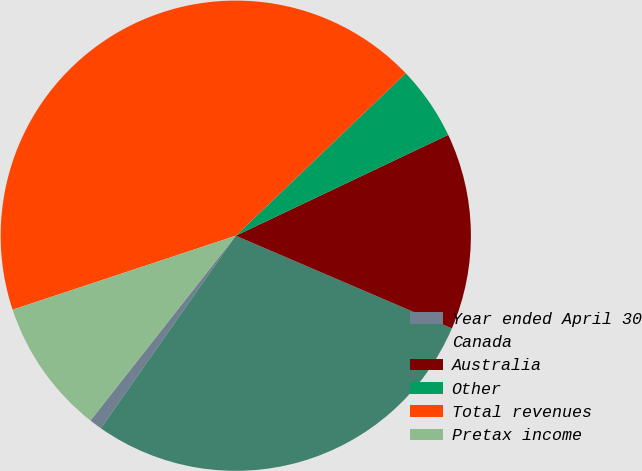Convert chart. <chart><loc_0><loc_0><loc_500><loc_500><pie_chart><fcel>Year ended April 30<fcel>Canada<fcel>Australia<fcel>Other<fcel>Total revenues<fcel>Pretax income<nl><fcel>0.88%<fcel>28.28%<fcel>13.5%<fcel>5.09%<fcel>42.95%<fcel>9.3%<nl></chart> 